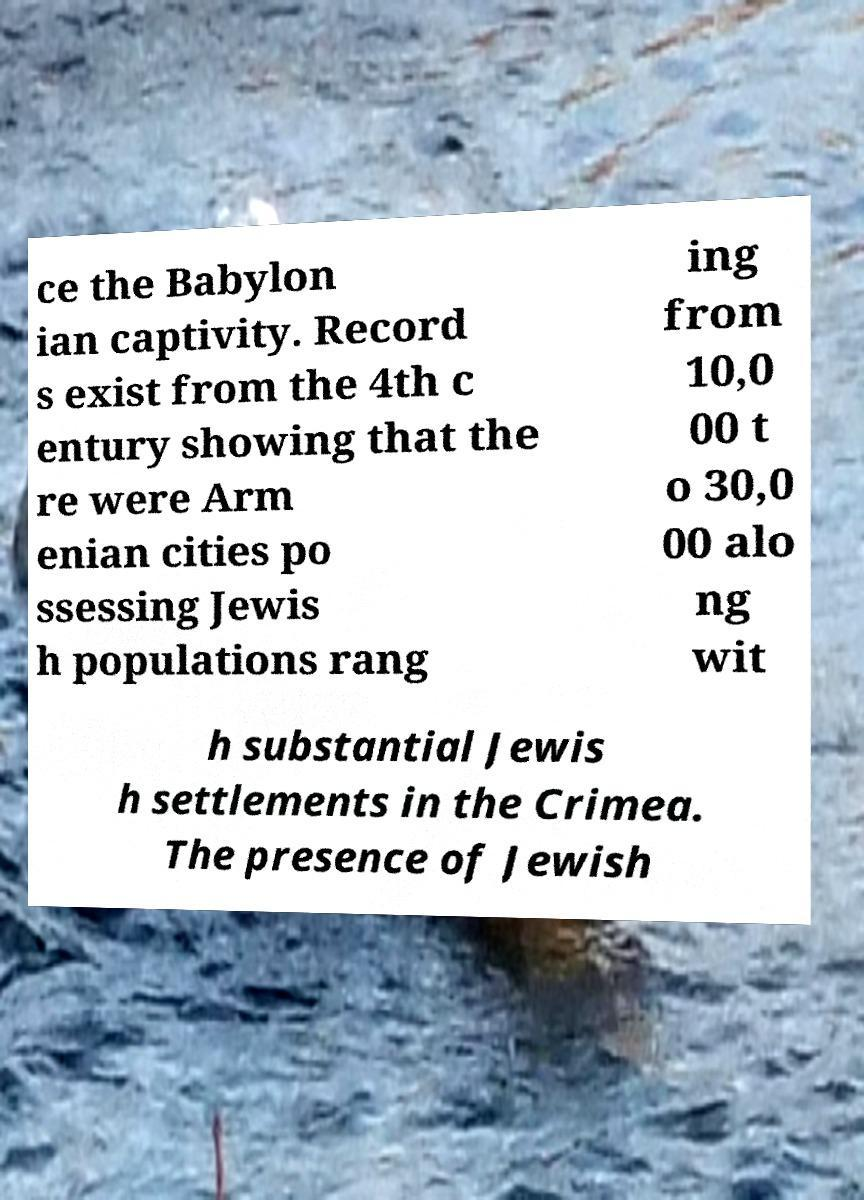There's text embedded in this image that I need extracted. Can you transcribe it verbatim? ce the Babylon ian captivity. Record s exist from the 4th c entury showing that the re were Arm enian cities po ssessing Jewis h populations rang ing from 10,0 00 t o 30,0 00 alo ng wit h substantial Jewis h settlements in the Crimea. The presence of Jewish 